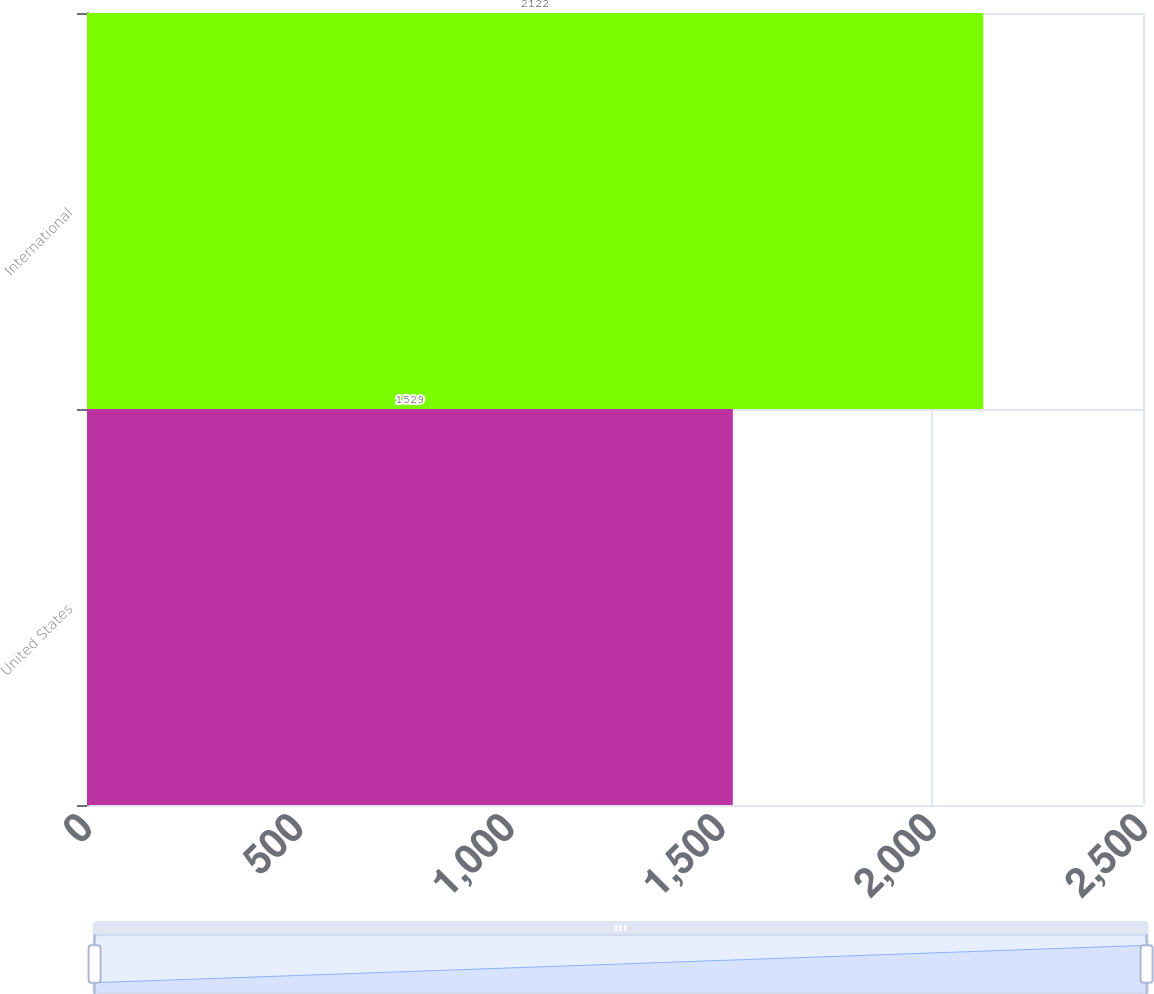Convert chart. <chart><loc_0><loc_0><loc_500><loc_500><bar_chart><fcel>United States<fcel>International<nl><fcel>1529<fcel>2122<nl></chart> 